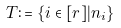<formula> <loc_0><loc_0><loc_500><loc_500>T \colon = \{ i \in [ r ] | n _ { i } \}</formula> 